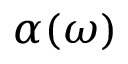Convert formula to latex. <formula><loc_0><loc_0><loc_500><loc_500>\alpha ( \omega )</formula> 